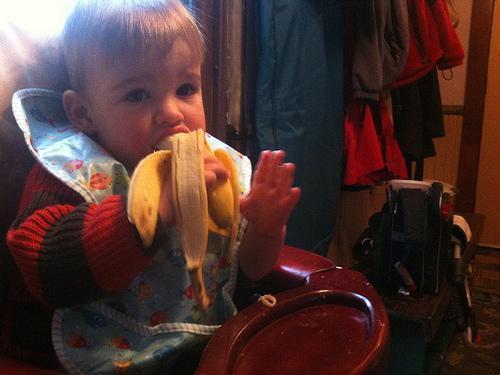How many babies are there?
Give a very brief answer. 1. 